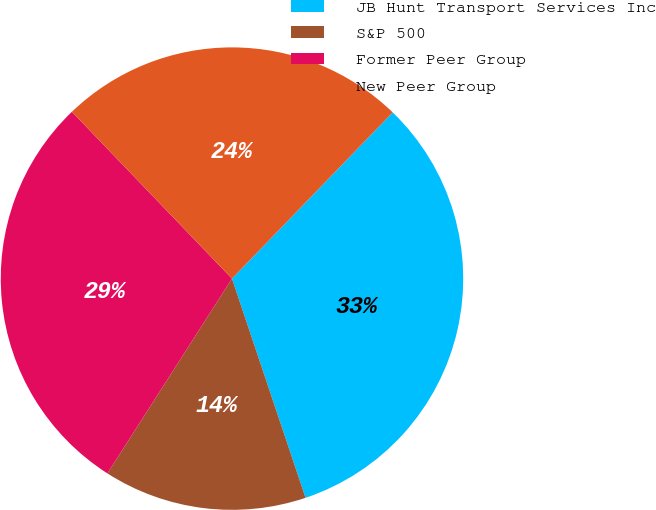Convert chart to OTSL. <chart><loc_0><loc_0><loc_500><loc_500><pie_chart><fcel>JB Hunt Transport Services Inc<fcel>S&P 500<fcel>Former Peer Group<fcel>New Peer Group<nl><fcel>32.61%<fcel>14.21%<fcel>28.77%<fcel>24.4%<nl></chart> 